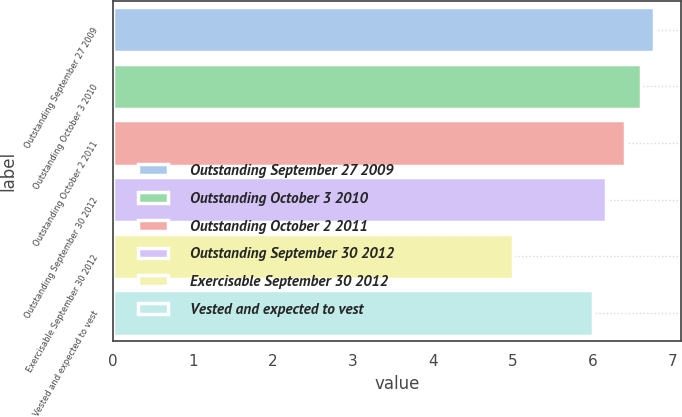<chart> <loc_0><loc_0><loc_500><loc_500><bar_chart><fcel>Outstanding September 27 2009<fcel>Outstanding October 3 2010<fcel>Outstanding October 2 2011<fcel>Outstanding September 30 2012<fcel>Exercisable September 30 2012<fcel>Vested and expected to vest<nl><fcel>6.77<fcel>6.6<fcel>6.4<fcel>6.17<fcel>5<fcel>6<nl></chart> 